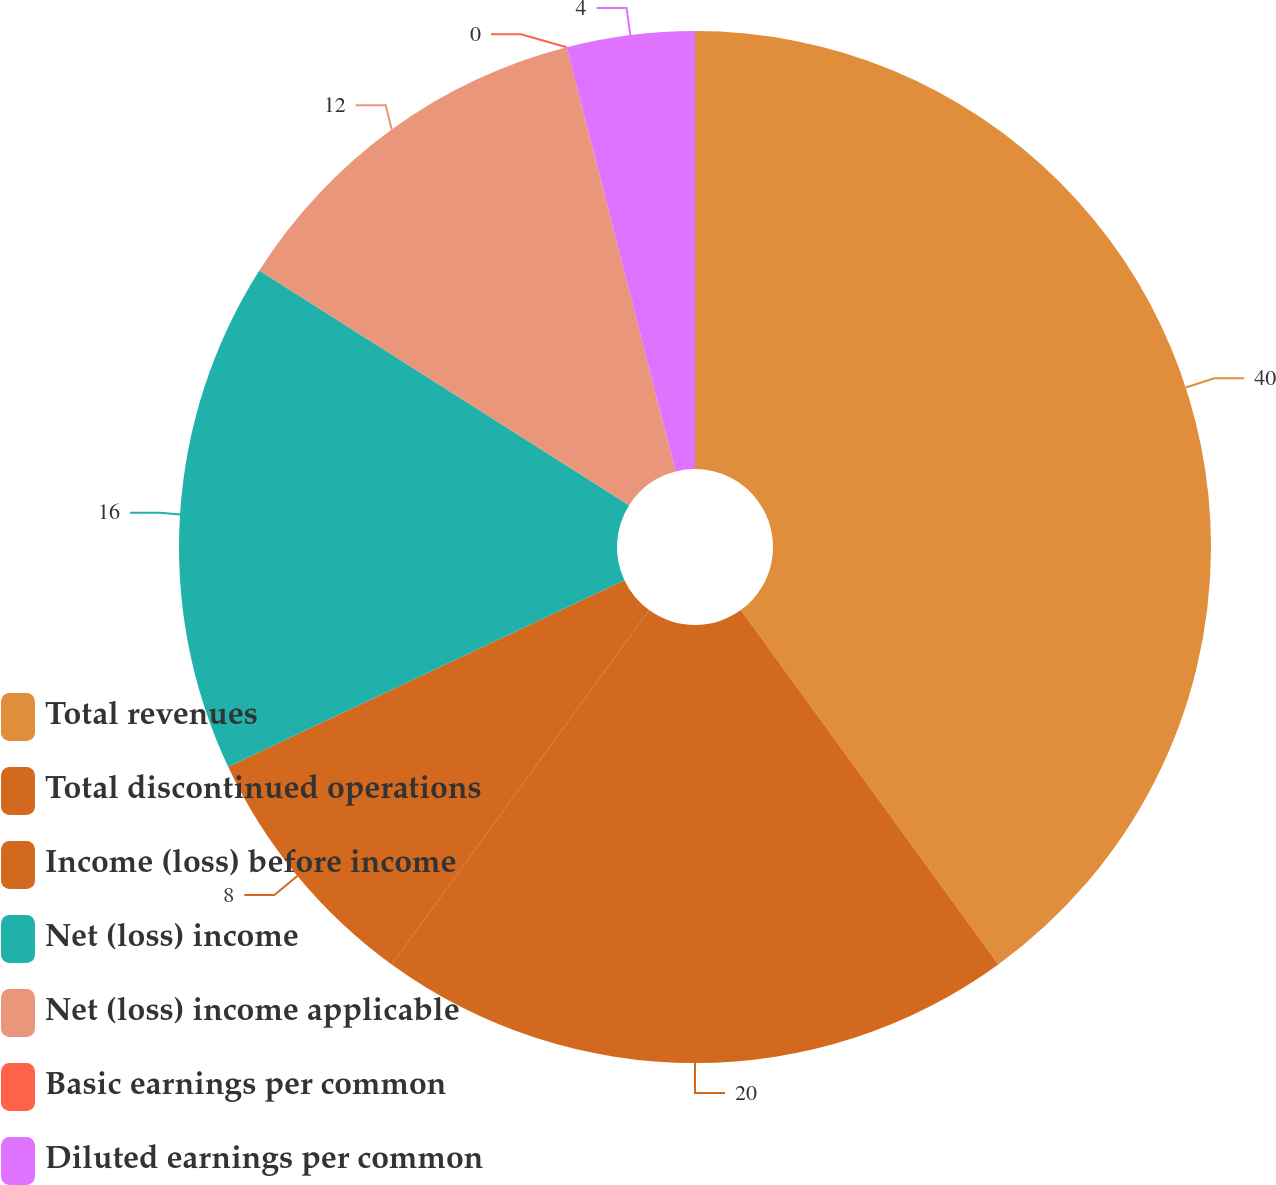Convert chart. <chart><loc_0><loc_0><loc_500><loc_500><pie_chart><fcel>Total revenues<fcel>Total discontinued operations<fcel>Income (loss) before income<fcel>Net (loss) income<fcel>Net (loss) income applicable<fcel>Basic earnings per common<fcel>Diluted earnings per common<nl><fcel>40.0%<fcel>20.0%<fcel>8.0%<fcel>16.0%<fcel>12.0%<fcel>0.0%<fcel>4.0%<nl></chart> 